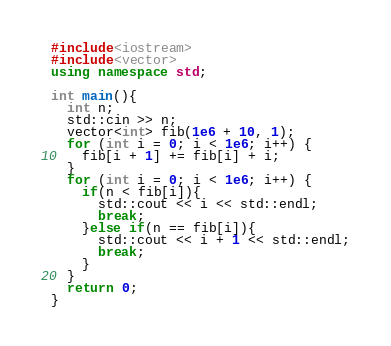<code> <loc_0><loc_0><loc_500><loc_500><_C++_>#include<iostream>
#include<vector>
using namespace std;

int main(){
  int n;
  std::cin >> n;
  vector<int> fib(1e6 + 10, 1);
  for (int i = 0; i < 1e6; i++) {
    fib[i + 1] += fib[i] + i;
  }
  for (int i = 0; i < 1e6; i++) {
    if(n < fib[i]){
      std::cout << i << std::endl;
      break;
    }else if(n == fib[i]){
      std::cout << i + 1 << std::endl;
      break;
    }
  }
  return 0;
}
</code> 